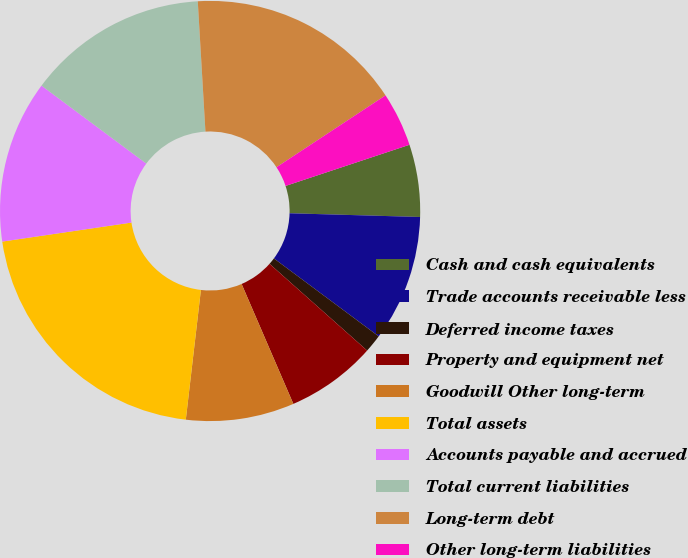<chart> <loc_0><loc_0><loc_500><loc_500><pie_chart><fcel>Cash and cash equivalents<fcel>Trade accounts receivable less<fcel>Deferred income taxes<fcel>Property and equipment net<fcel>Goodwill Other long-term<fcel>Total assets<fcel>Accounts payable and accrued<fcel>Total current liabilities<fcel>Long-term debt<fcel>Other long-term liabilities<nl><fcel>5.56%<fcel>9.72%<fcel>1.39%<fcel>6.95%<fcel>8.33%<fcel>20.83%<fcel>12.5%<fcel>13.89%<fcel>16.66%<fcel>4.17%<nl></chart> 